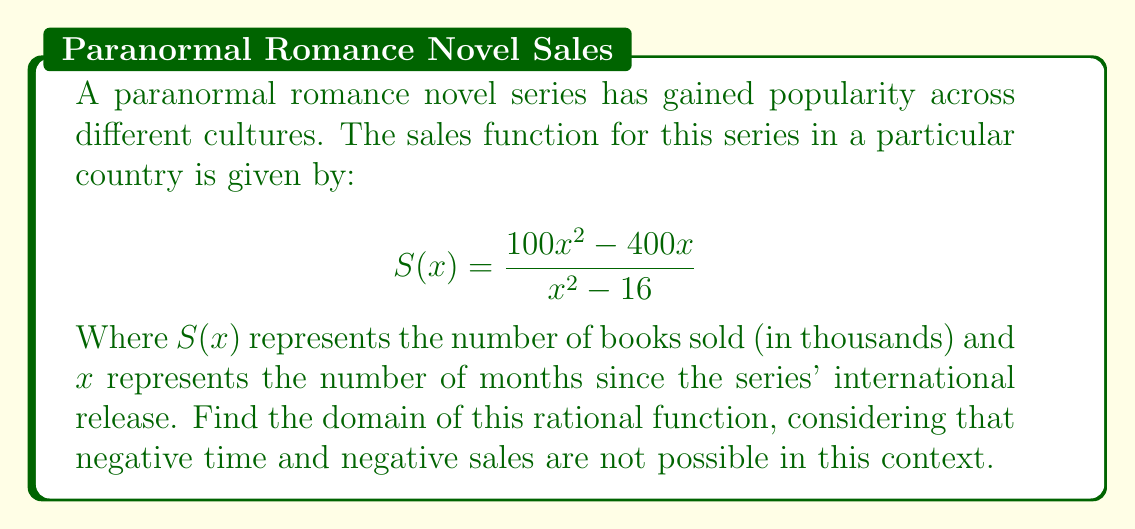Could you help me with this problem? To find the domain of this rational function, we need to follow these steps:

1) The domain of a rational function includes all real numbers except those that make the denominator equal to zero.

2) Set the denominator equal to zero and solve for x:
   $$x^2 - 16 = 0$$
   $$(x+4)(x-4) = 0$$
   $$x = -4 \text{ or } x = 4$$

3) These values of x (4 and -4) are excluded from the domain.

4) However, we need to consider the context:
   - Negative time (x < 0) doesn't make sense for book sales after release.
   - x = 0 would represent the moment of release, which is valid.

5) Therefore, the domain should be all non-negative real numbers except 4.

6) In interval notation, this is written as [0, 4) ∪ (4, ∞).
Answer: [0, 4) ∪ (4, ∞) 